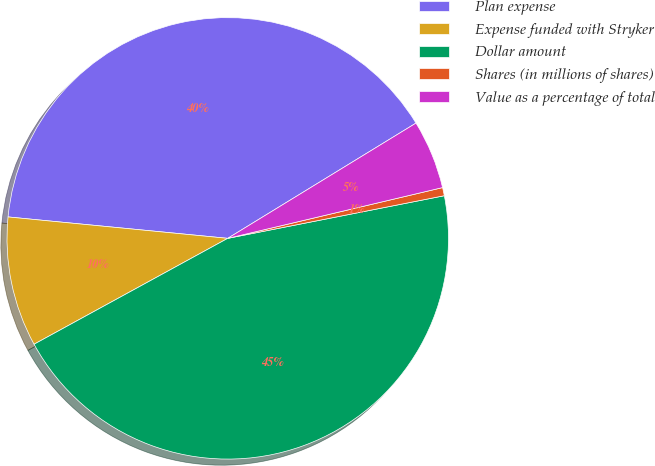Convert chart to OTSL. <chart><loc_0><loc_0><loc_500><loc_500><pie_chart><fcel>Plan expense<fcel>Expense funded with Stryker<fcel>Dollar amount<fcel>Shares (in millions of shares)<fcel>Value as a percentage of total<nl><fcel>39.71%<fcel>9.51%<fcel>45.13%<fcel>0.6%<fcel>5.05%<nl></chart> 